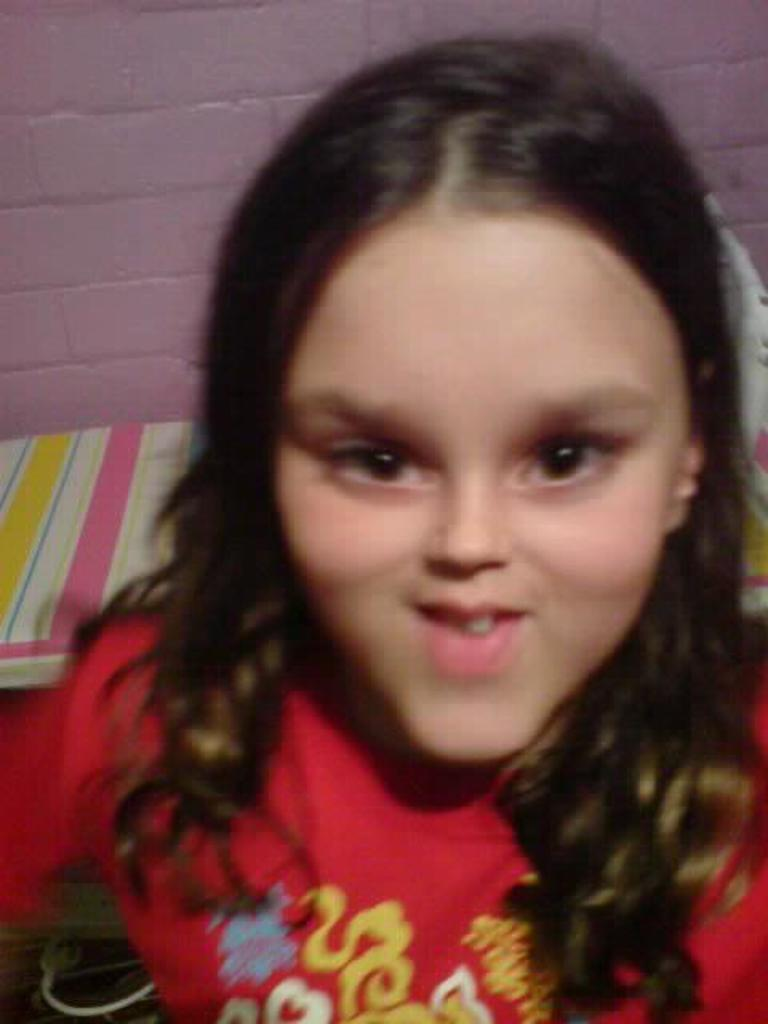Who is the main subject in the image? There is a lady in the image. What is the lady wearing? The lady is wearing a red dress. What can be seen in the background of the image? There is a pink color wall in the background of the image. What role does the lady's grandfather play in the image? There is no mention of a grandfather in the image, so it is not possible to determine his role. 